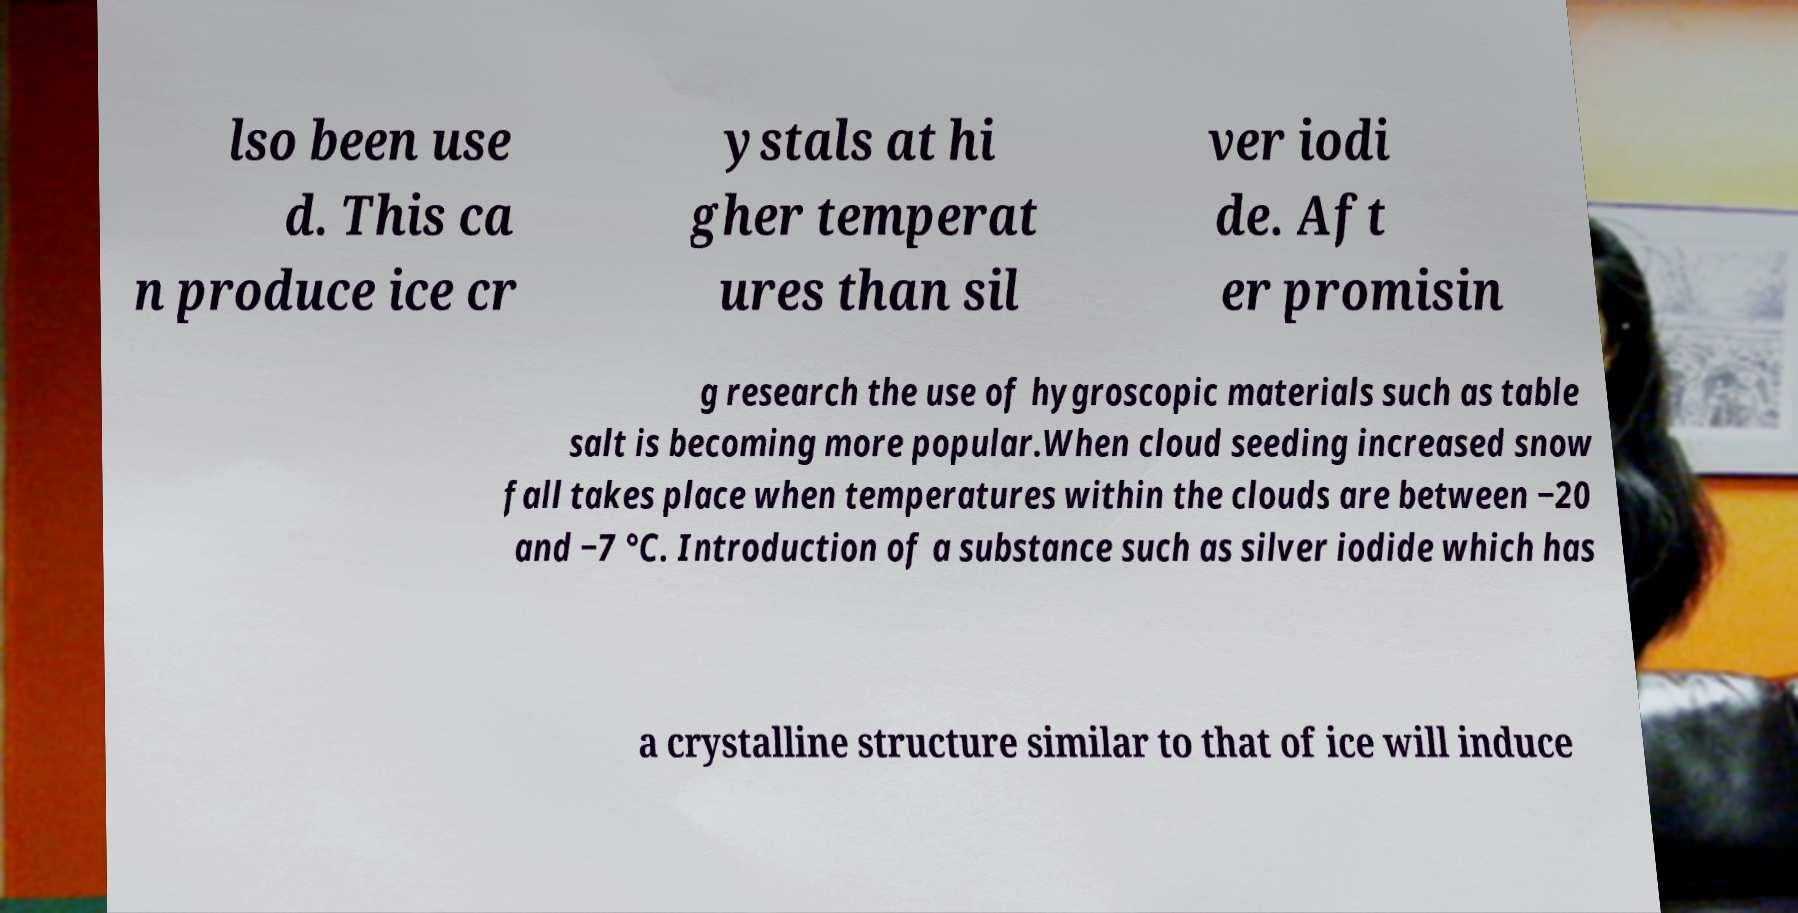Can you read and provide the text displayed in the image?This photo seems to have some interesting text. Can you extract and type it out for me? lso been use d. This ca n produce ice cr ystals at hi gher temperat ures than sil ver iodi de. Aft er promisin g research the use of hygroscopic materials such as table salt is becoming more popular.When cloud seeding increased snow fall takes place when temperatures within the clouds are between −20 and −7 °C. Introduction of a substance such as silver iodide which has a crystalline structure similar to that of ice will induce 